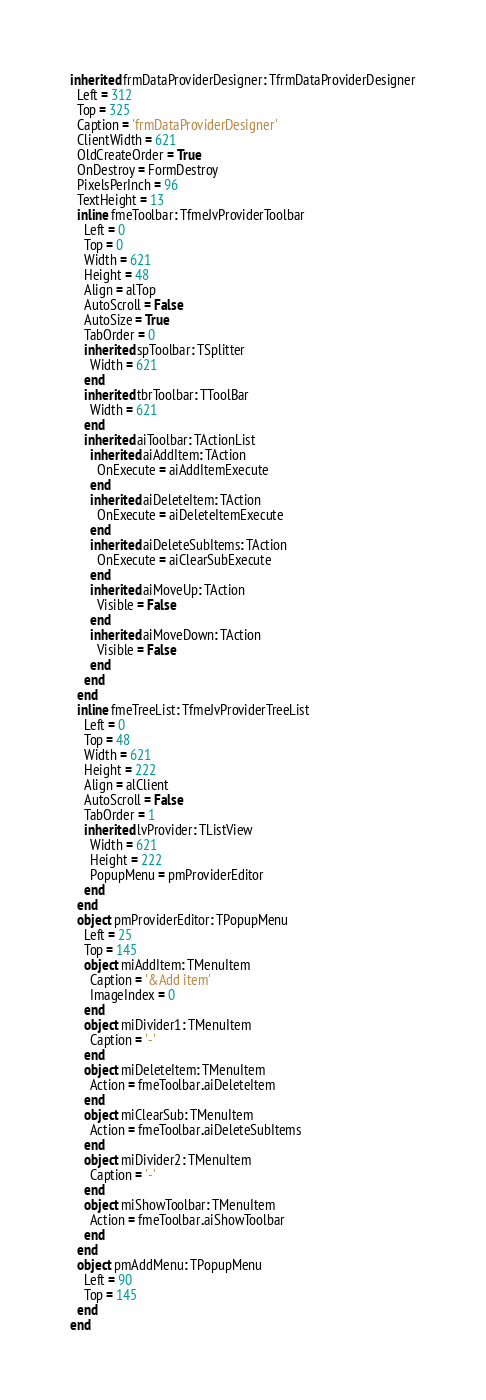Convert code to text. <code><loc_0><loc_0><loc_500><loc_500><_Pascal_>inherited frmDataProviderDesigner: TfrmDataProviderDesigner
  Left = 312
  Top = 325
  Caption = 'frmDataProviderDesigner'
  ClientWidth = 621
  OldCreateOrder = True
  OnDestroy = FormDestroy
  PixelsPerInch = 96
  TextHeight = 13
  inline fmeToolbar: TfmeJvProviderToolbar
    Left = 0
    Top = 0
    Width = 621
    Height = 48
    Align = alTop
    AutoScroll = False
    AutoSize = True
    TabOrder = 0
    inherited spToolbar: TSplitter
      Width = 621
    end
    inherited tbrToolbar: TToolBar
      Width = 621
    end
    inherited aiToolbar: TActionList
      inherited aiAddItem: TAction
        OnExecute = aiAddItemExecute
      end
      inherited aiDeleteItem: TAction
        OnExecute = aiDeleteItemExecute
      end
      inherited aiDeleteSubItems: TAction
        OnExecute = aiClearSubExecute
      end
      inherited aiMoveUp: TAction
        Visible = False
      end
      inherited aiMoveDown: TAction
        Visible = False
      end
    end
  end
  inline fmeTreeList: TfmeJvProviderTreeList
    Left = 0
    Top = 48
    Width = 621
    Height = 222
    Align = alClient
    AutoScroll = False
    TabOrder = 1
    inherited lvProvider: TListView
      Width = 621
      Height = 222
      PopupMenu = pmProviderEditor
    end
  end
  object pmProviderEditor: TPopupMenu
    Left = 25
    Top = 145
    object miAddItem: TMenuItem
      Caption = '&Add item'
      ImageIndex = 0
    end
    object miDivider1: TMenuItem
      Caption = '-'
    end
    object miDeleteItem: TMenuItem
      Action = fmeToolbar.aiDeleteItem
    end
    object miClearSub: TMenuItem
      Action = fmeToolbar.aiDeleteSubItems
    end
    object miDivider2: TMenuItem
      Caption = '-'
    end
    object miShowToolbar: TMenuItem
      Action = fmeToolbar.aiShowToolbar
    end
  end
  object pmAddMenu: TPopupMenu
    Left = 90
    Top = 145
  end
end
</code> 